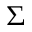<formula> <loc_0><loc_0><loc_500><loc_500>\Sigma</formula> 